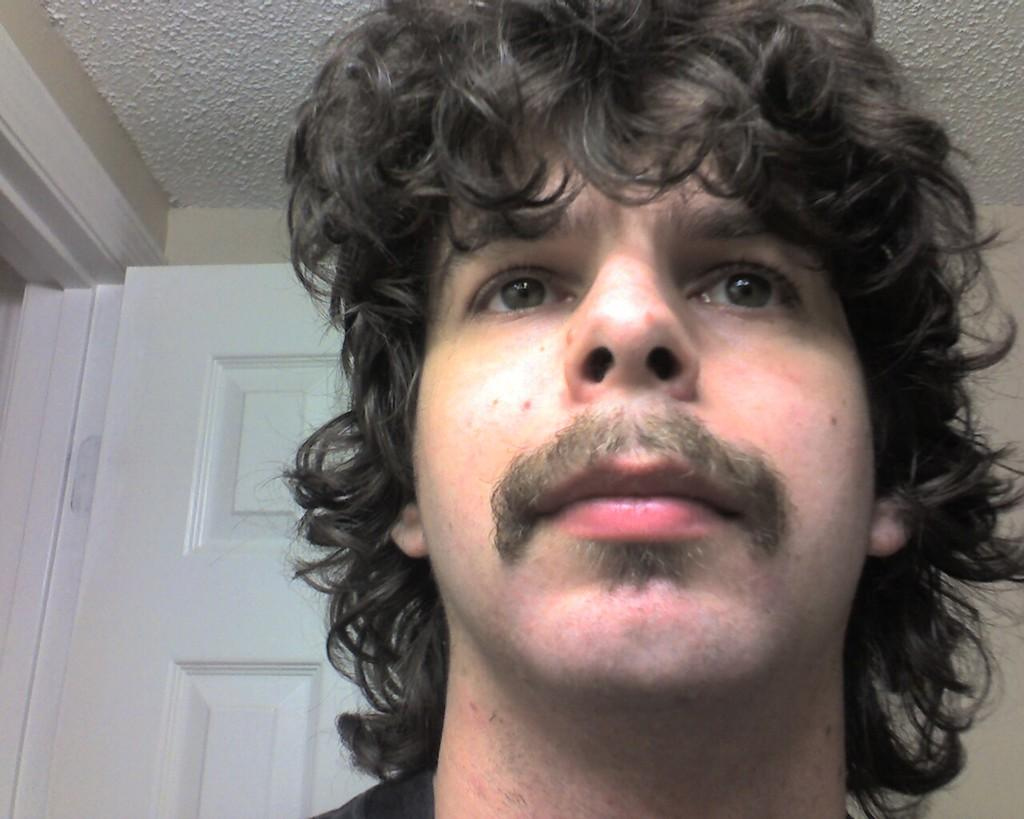What is the main subject of the image? The main subject of the image is a person's head. What can be seen on the left side of the image? There is a door on the left side of the image. What is visible in the background of the image? There is a wall visible in the background of the image. What is the person's head's tendency to lean towards the door in the image? There is no indication of the person's head leaning towards the door in the image. 